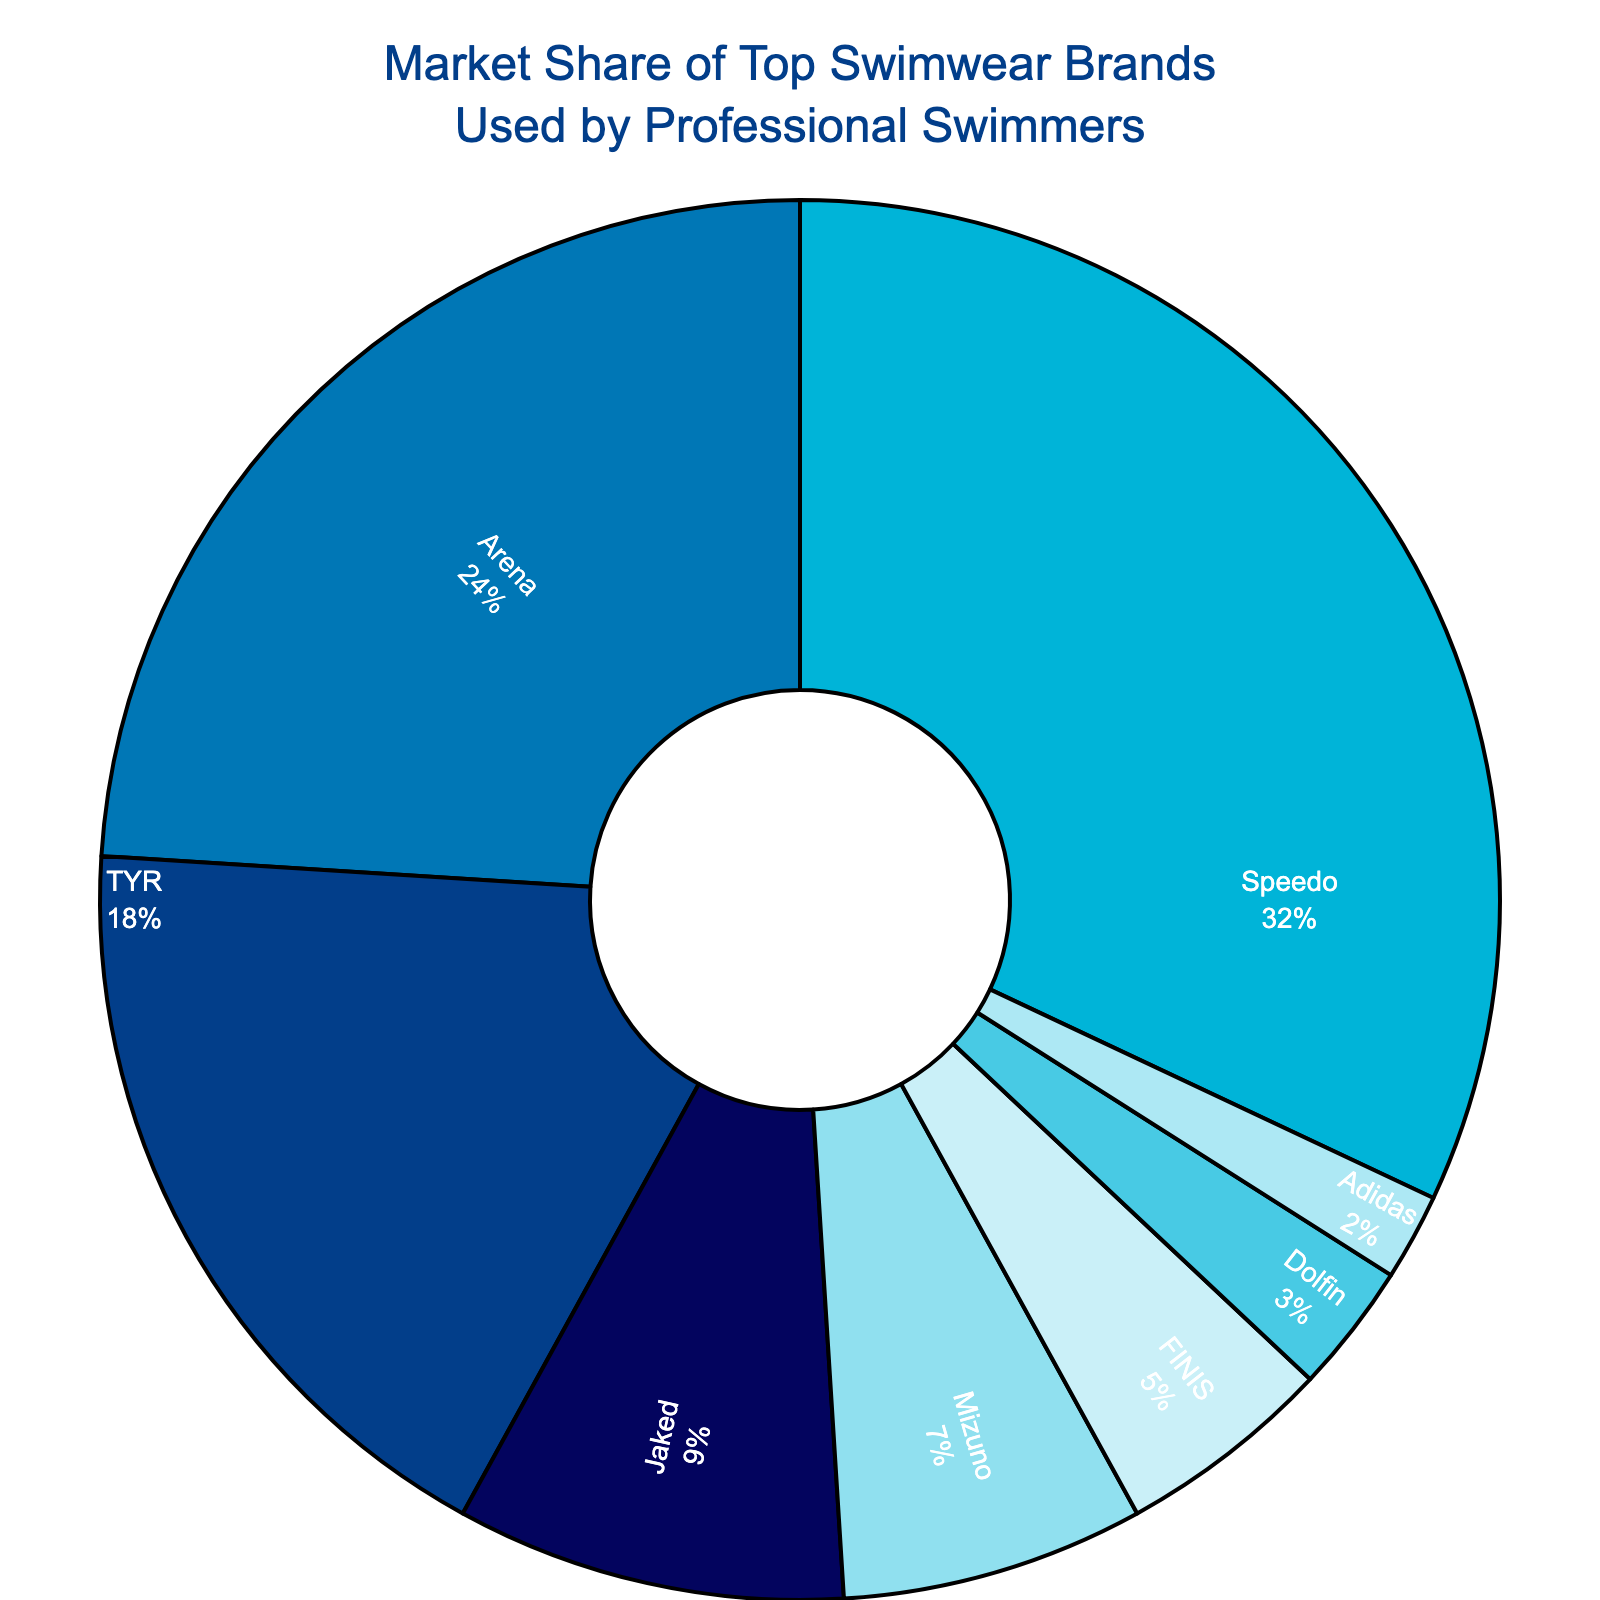Which swimwear brand holds the largest market share among professional swimmers? The pie chart shows the market shares, and the largest segment belongs to Speedo with 32%.
Answer: Speedo Which two brands have the closest market shares? By examining the pie chart, TYR and Jaked have market shares of 18% and 9% respectively. The next closest brands are Mizuno with 7% and FINIS with 5%. 7% - 5% = 2% which is smaller than 18% - 9% = 9%. Therefore, Mizuno and FINIS have the closest market shares.
Answer: Mizuno and FINIS How much more market share does Speedo have compared to Arena? Speedo has 32% and Arena has 24%. The difference is calculated as 32% - 24% = 8%.
Answer: 8% Which brand has the smallest market share, and what is its market percentage? The smallest segment in the pie chart belongs to Adidas with a market share of 2%.
Answer: Adidas with 2% What is the combined market share of the three leading brands? The leading brands are Speedo (32%), Arena (24%), and TYR (18%). Adding these together: 32% + 24% + 18% = 74%.
Answer: 74% Which brands have a market share under 10%? By looking at the chart, Jaked (9%), Mizuno (7%), FINIS (5%), Dolfin (3%), and Adidas (2%) all have market shares under 10%.
Answer: Jaked, Mizuno, FINIS, Dolfin, Adidas How much more market share does Speedo have compared to the combined market share of Dolfin and Adidas? Speedo has 32%, Dolfin has 3%, and Adidas has 2%. Combined, Dolfin and Adidas have 3% + 2% = 5%. Comparing this to Speedo: 32% - 5% = 27%.
Answer: 27% Which two brands together have a market share closest to TYR's market share? TYR has a market share of 18%. Looking at the pie chart, Mizuno (7%) and FINIS (5%) together have 7% + 5% = 12%, and adding Dolfin's 3% gives 15%. Another pair is FINIS and Dolfin, together having 5% + 3% = 8%. The closest match is Mizuno and FINIS with a total of 12% which equals TYR's market share.
Answer: Mizuno and FINIS What proportion of the market share do the lower half of the brands (Mizuno, FINIS, Dolfin, Adidas) hold? Mizuno (7%), FINIS (5%), Dolfin (3%), and Adidas (2%) combined: 7% + 5% + 3% + 2% = 17%.
Answer: 17% 